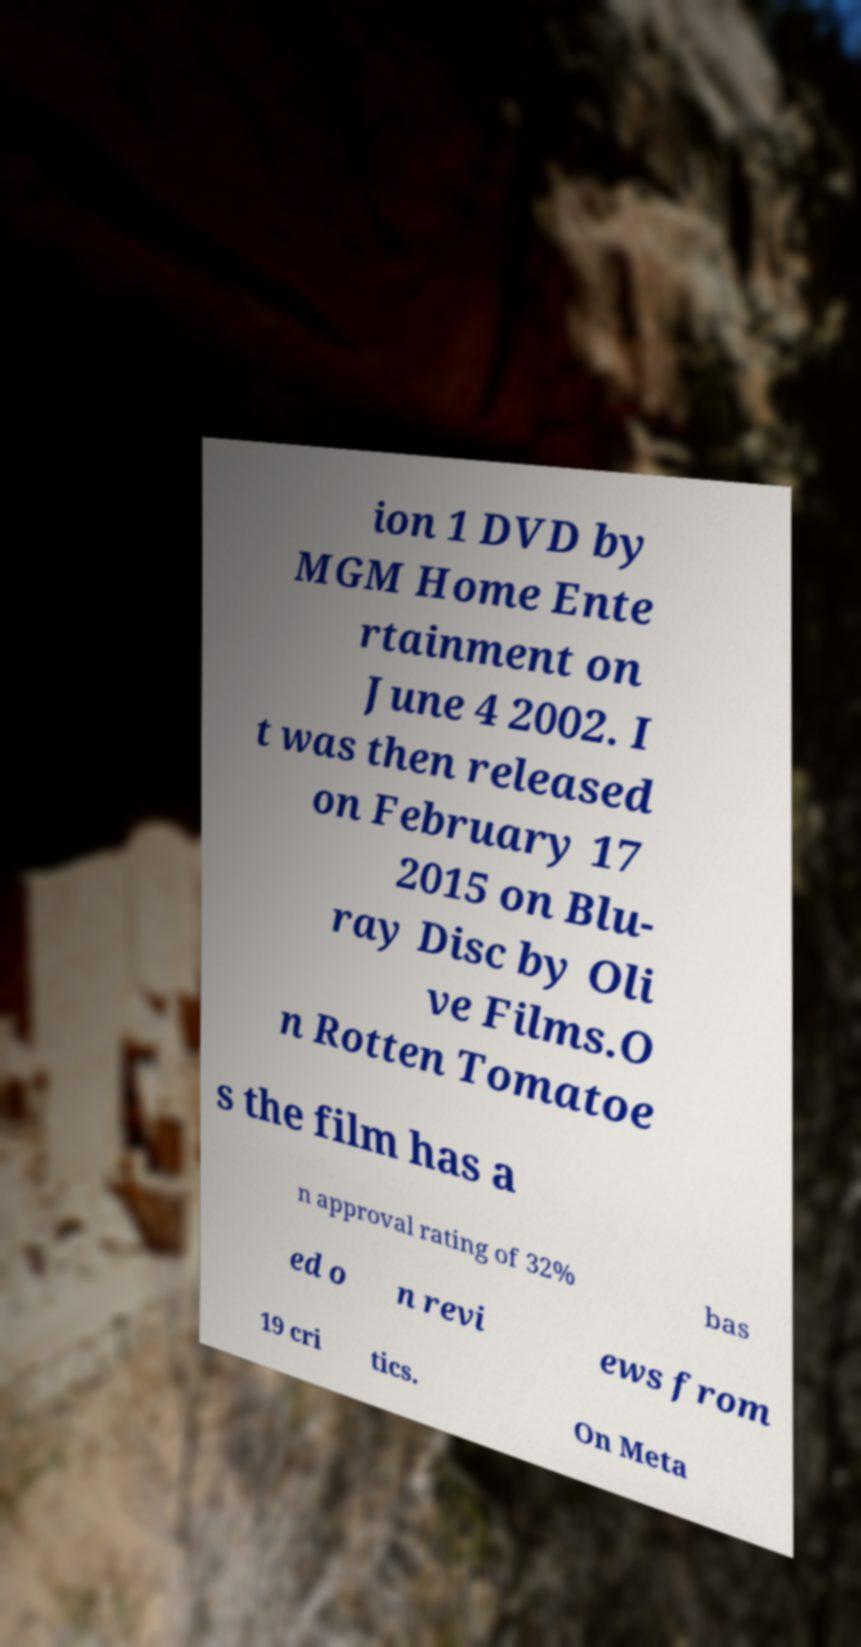Please read and relay the text visible in this image. What does it say? ion 1 DVD by MGM Home Ente rtainment on June 4 2002. I t was then released on February 17 2015 on Blu- ray Disc by Oli ve Films.O n Rotten Tomatoe s the film has a n approval rating of 32% bas ed o n revi ews from 19 cri tics. On Meta 